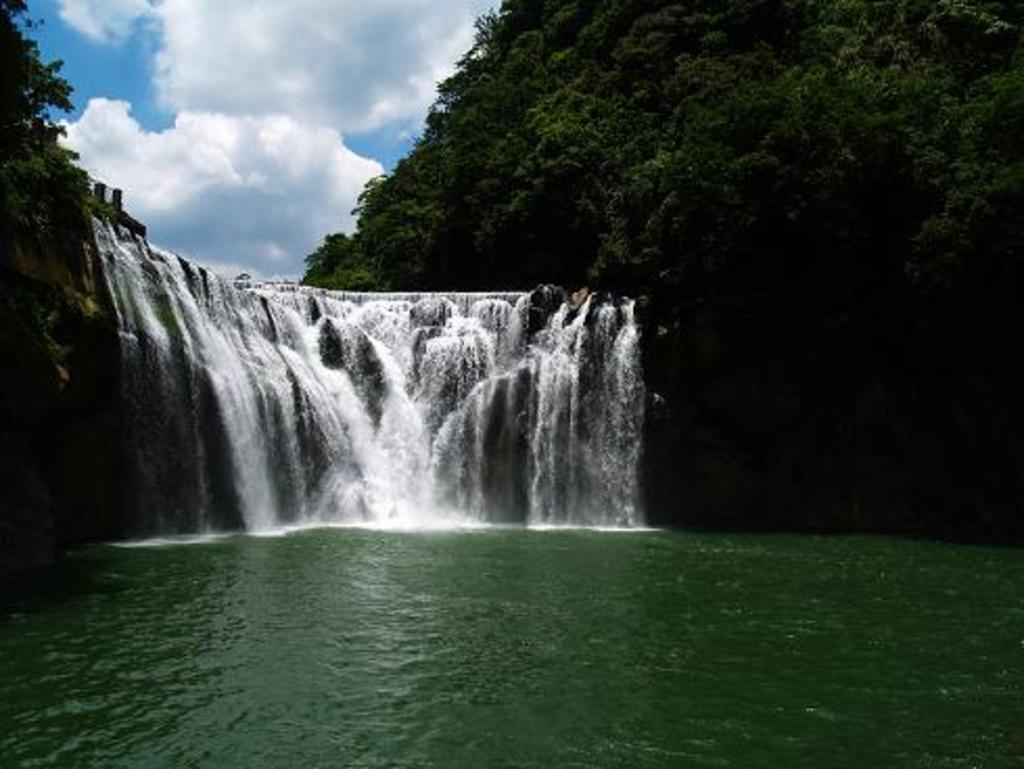What natural feature is the main subject of the image? There is a waterfall in the image. What type of vegetation is on the right side of the image? There are trees on the right side of the image. What is visible at the top of the image? The sky is visible at the top of the image. Where is the bell located in the image? There is no bell present in the image. What type of juice can be seen dripping from the trees in the image? There is no juice dripping from the trees in the image; it is a waterfall and trees. 